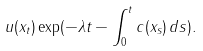<formula> <loc_0><loc_0><loc_500><loc_500>u ( x _ { t } ) \exp ( - \lambda t - \int _ { 0 } ^ { t } c ( x _ { s } ) \, d s ) .</formula> 